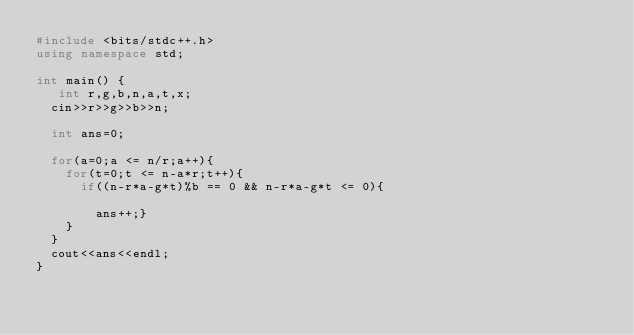Convert code to text. <code><loc_0><loc_0><loc_500><loc_500><_C++_>#include <bits/stdc++.h>
using namespace std;

int main() {
   int r,g,b,n,a,t,x;
  cin>>r>>g>>b>>n;
  
  int ans=0;
  
  for(a=0;a <= n/r;a++){
    for(t=0;t <= n-a*r;t++){
      if((n-r*a-g*t)%b == 0 && n-r*a-g*t <= 0){
        
        ans++;}
    }
  }
  cout<<ans<<endl;
}
</code> 